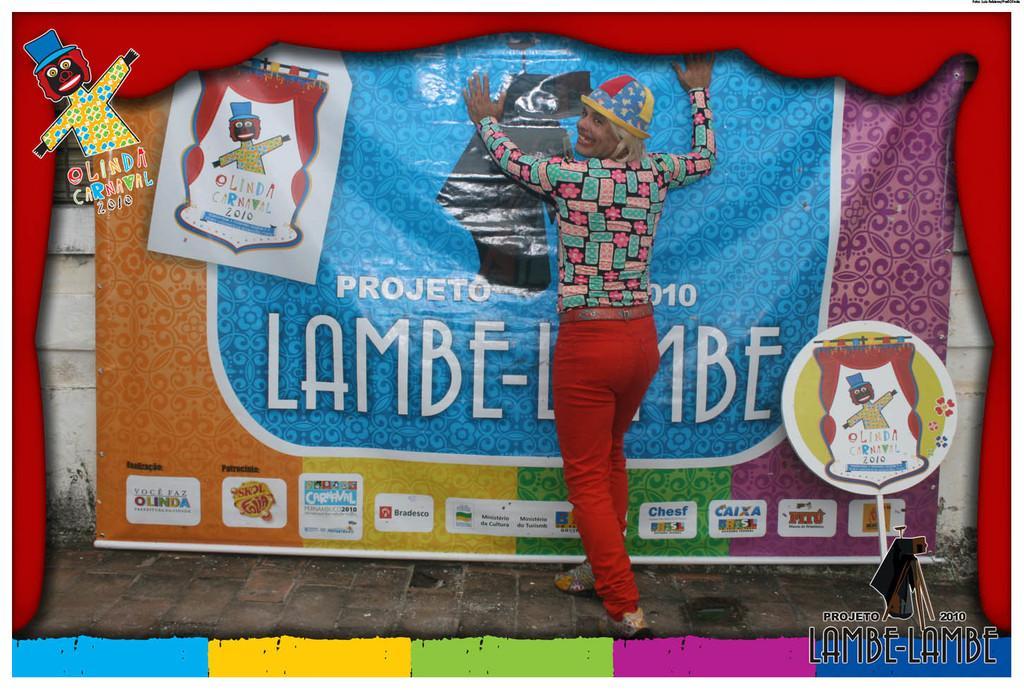In one or two sentences, can you explain what this image depicts? It is an edited image, there is a person standing by keeping the hands on the poster and there is a colorful frame design around the picture. 